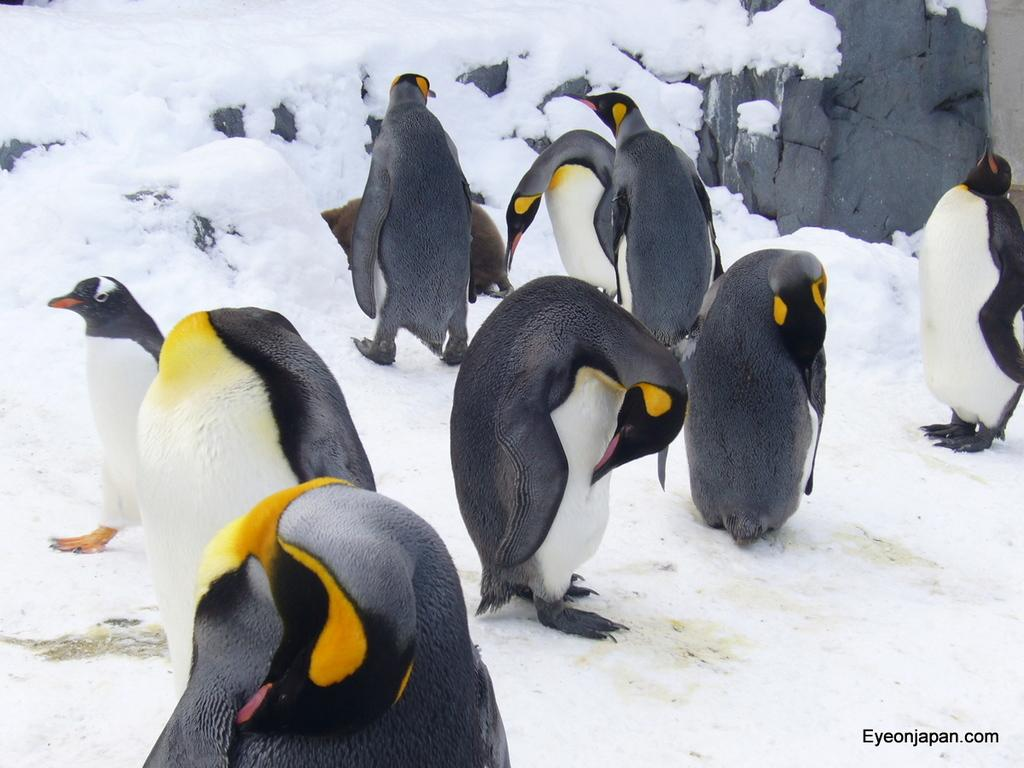What animals are in the center of the image? There are penguins in the center of the image. What type of terrain is visible at the bottom of the image? There is snow at the bottom of the image. What object can be seen on the right side of the image? There is a rock on the right side of the image. What type of substance is being blown by the horn in the image? There is no horn present in the image, so it is not possible to determine what substance might be blown by it. 